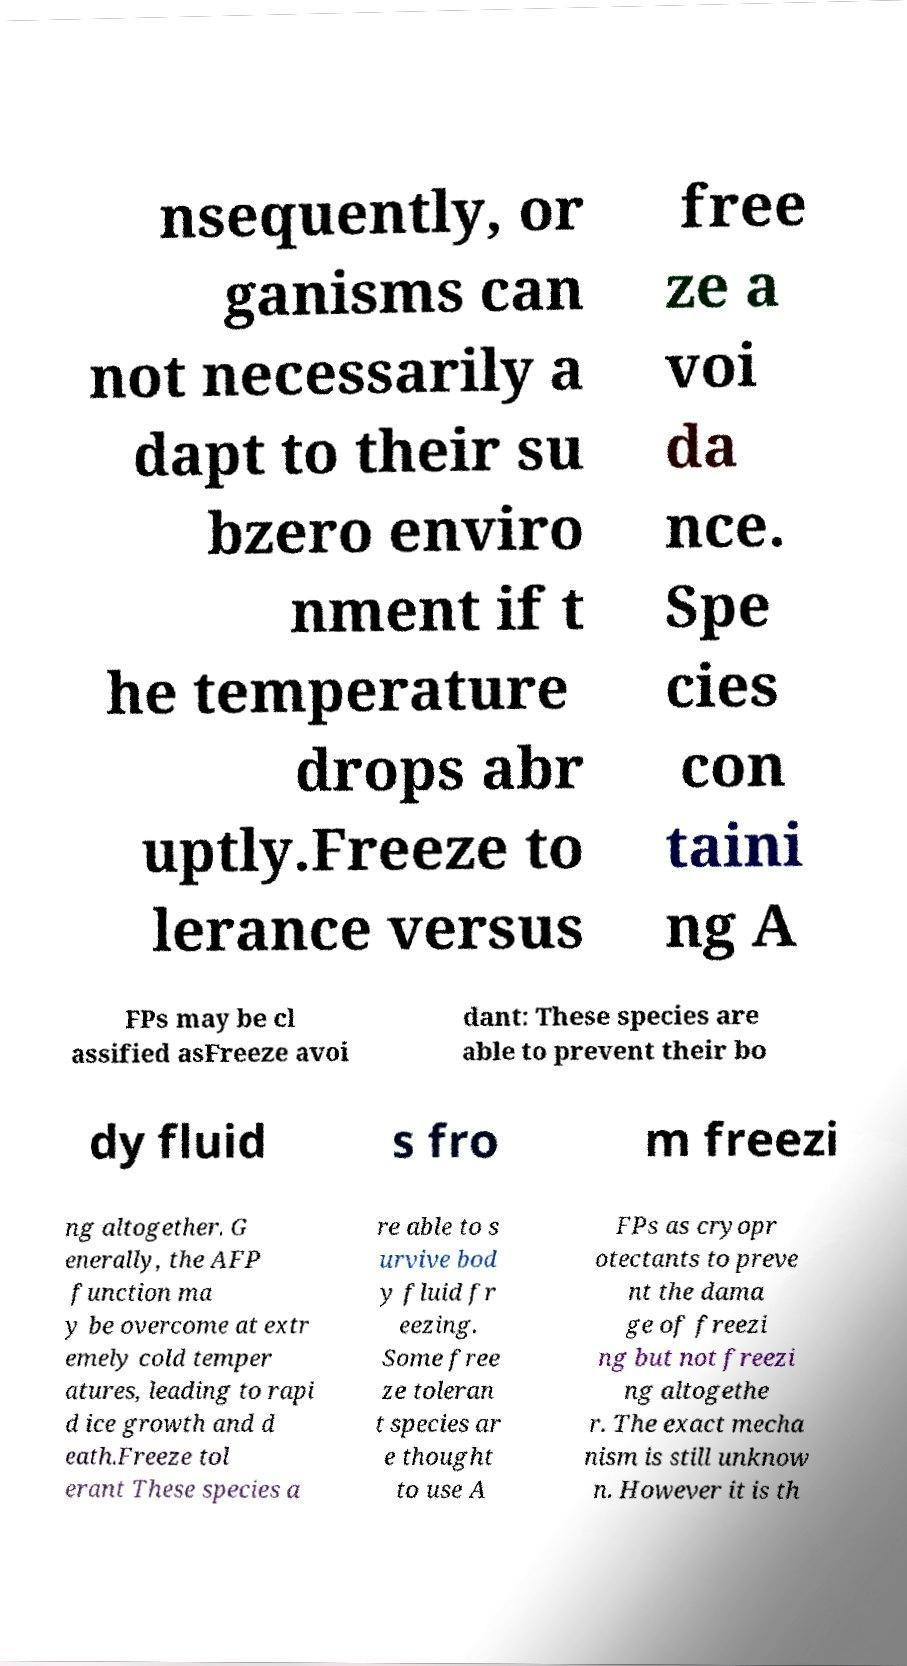Can you read and provide the text displayed in the image?This photo seems to have some interesting text. Can you extract and type it out for me? nsequently, or ganisms can not necessarily a dapt to their su bzero enviro nment if t he temperature drops abr uptly.Freeze to lerance versus free ze a voi da nce. Spe cies con taini ng A FPs may be cl assified asFreeze avoi dant: These species are able to prevent their bo dy fluid s fro m freezi ng altogether. G enerally, the AFP function ma y be overcome at extr emely cold temper atures, leading to rapi d ice growth and d eath.Freeze tol erant These species a re able to s urvive bod y fluid fr eezing. Some free ze toleran t species ar e thought to use A FPs as cryopr otectants to preve nt the dama ge of freezi ng but not freezi ng altogethe r. The exact mecha nism is still unknow n. However it is th 